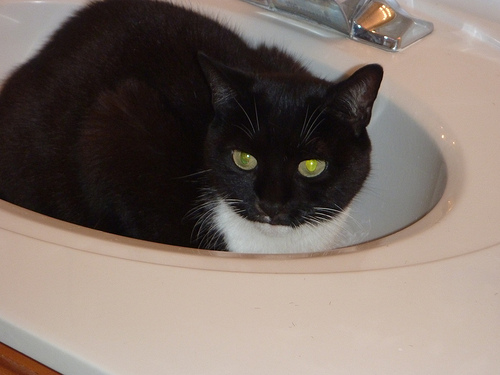What might this cat be thinking while sitting in the sink? If I had to guess, the cat may be thinking how perfectly the sink cradles its body and provides a secure, elevated spot to observe the surroundings with comfort. 